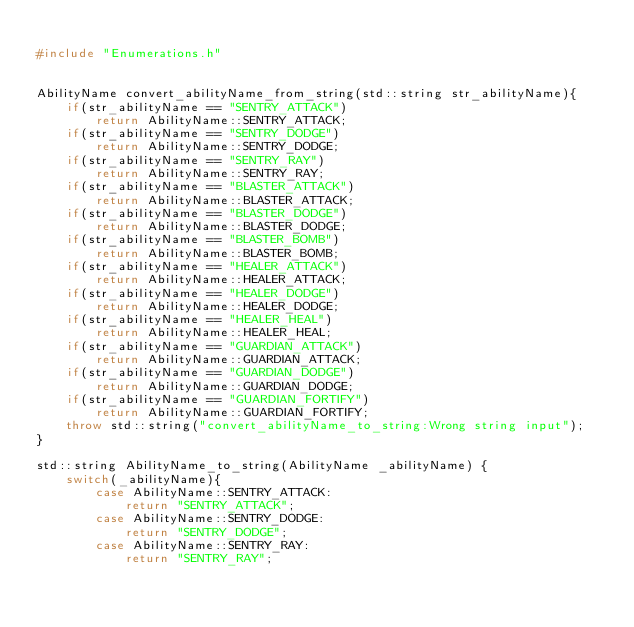Convert code to text. <code><loc_0><loc_0><loc_500><loc_500><_C++_>
#include "Enumerations.h"


AbilityName convert_abilityName_from_string(std::string str_abilityName){
    if(str_abilityName == "SENTRY_ATTACK")
        return AbilityName::SENTRY_ATTACK;
    if(str_abilityName == "SENTRY_DODGE")
        return AbilityName::SENTRY_DODGE;
    if(str_abilityName == "SENTRY_RAY")
        return AbilityName::SENTRY_RAY;
    if(str_abilityName == "BLASTER_ATTACK")
        return AbilityName::BLASTER_ATTACK;
    if(str_abilityName == "BLASTER_DODGE")
        return AbilityName::BLASTER_DODGE;
    if(str_abilityName == "BLASTER_BOMB")
        return AbilityName::BLASTER_BOMB;
    if(str_abilityName == "HEALER_ATTACK")
        return AbilityName::HEALER_ATTACK;
    if(str_abilityName == "HEALER_DODGE")
        return AbilityName::HEALER_DODGE;
    if(str_abilityName == "HEALER_HEAL")
        return AbilityName::HEALER_HEAL;
    if(str_abilityName == "GUARDIAN_ATTACK")
        return AbilityName::GUARDIAN_ATTACK;
    if(str_abilityName == "GUARDIAN_DODGE")
        return AbilityName::GUARDIAN_DODGE;
    if(str_abilityName == "GUARDIAN_FORTIFY")
        return AbilityName::GUARDIAN_FORTIFY;
    throw std::string("convert_abilityName_to_string:Wrong string input");
}

std::string AbilityName_to_string(AbilityName _abilityName) {
    switch(_abilityName){
        case AbilityName::SENTRY_ATTACK:
            return "SENTRY_ATTACK";
        case AbilityName::SENTRY_DODGE:
            return "SENTRY_DODGE";
        case AbilityName::SENTRY_RAY:
            return "SENTRY_RAY";</code> 